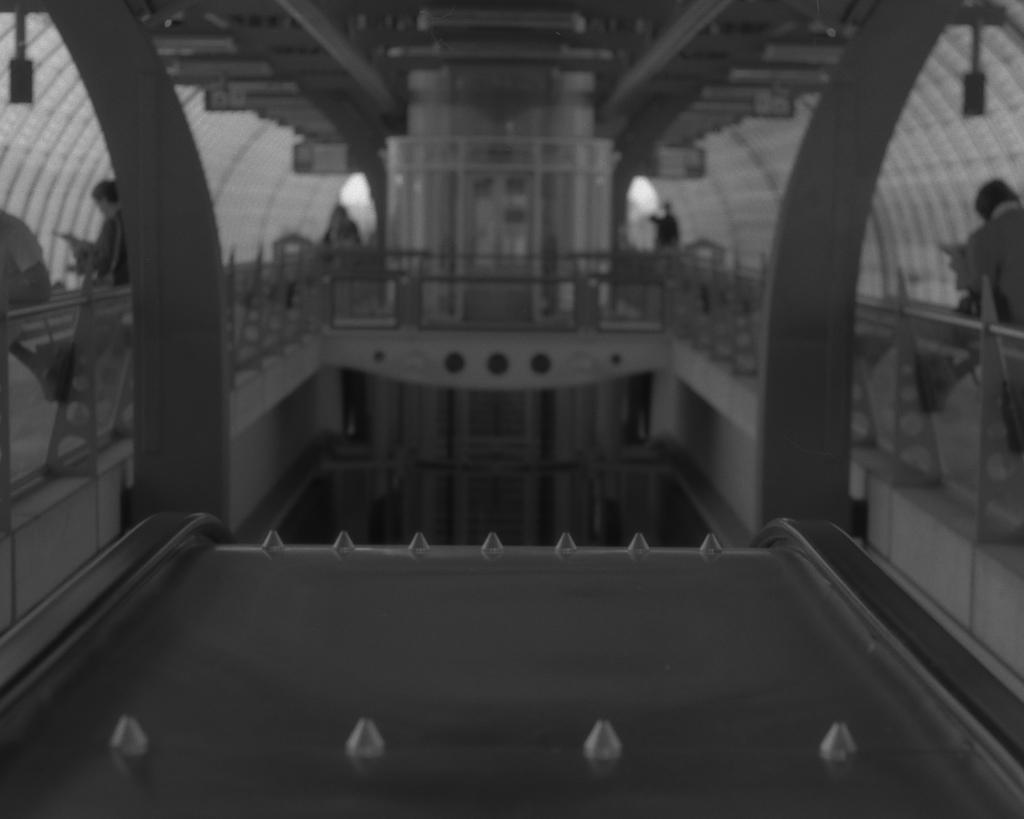Please provide a concise description of this image. In this picture there is a palace in the center of the image and there are people on the right and left side of the image. 